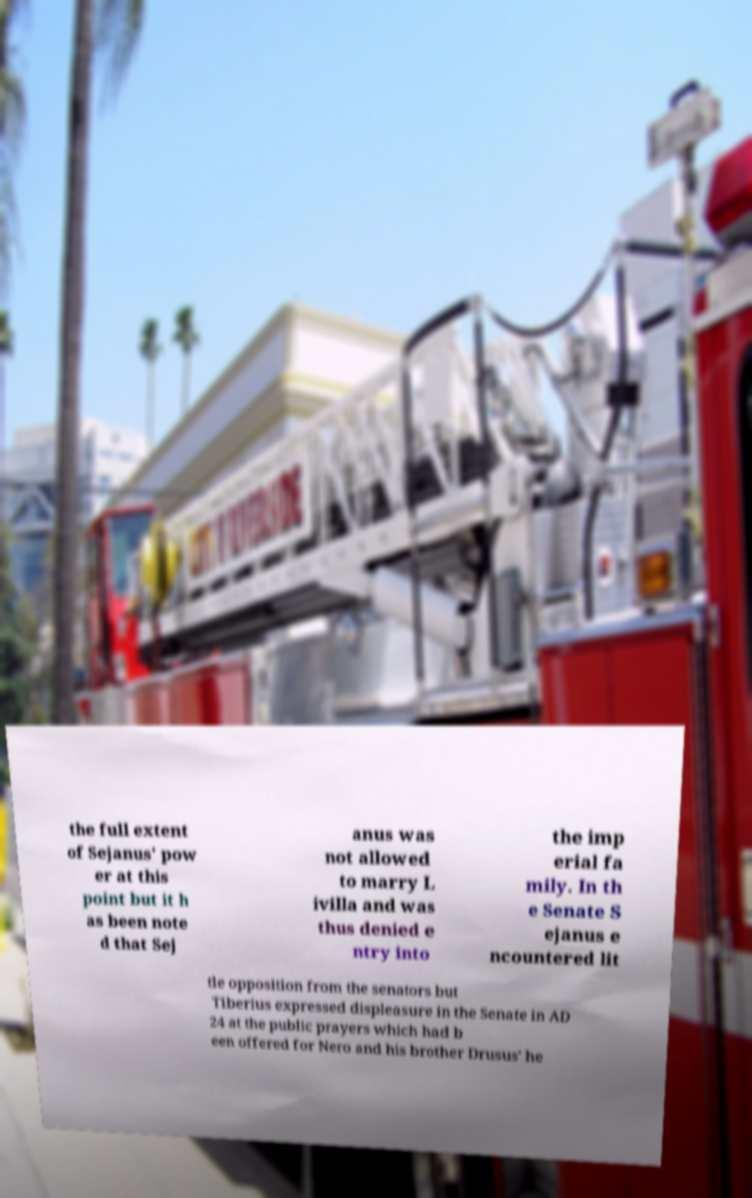For documentation purposes, I need the text within this image transcribed. Could you provide that? the full extent of Sejanus' pow er at this point but it h as been note d that Sej anus was not allowed to marry L ivilla and was thus denied e ntry into the imp erial fa mily. In th e Senate S ejanus e ncountered lit tle opposition from the senators but Tiberius expressed displeasure in the Senate in AD 24 at the public prayers which had b een offered for Nero and his brother Drusus' he 